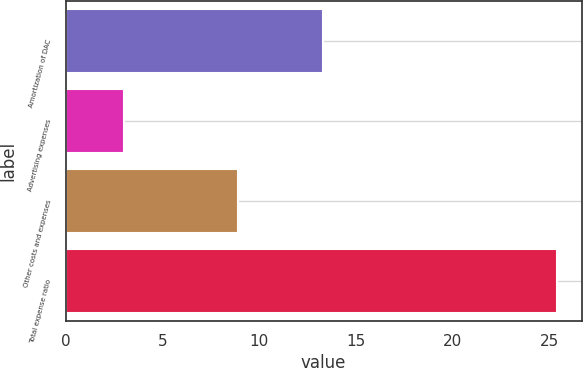<chart> <loc_0><loc_0><loc_500><loc_500><bar_chart><fcel>Amortization of DAC<fcel>Advertising expenses<fcel>Other costs and expenses<fcel>Total expense ratio<nl><fcel>13.3<fcel>3<fcel>8.9<fcel>25.4<nl></chart> 